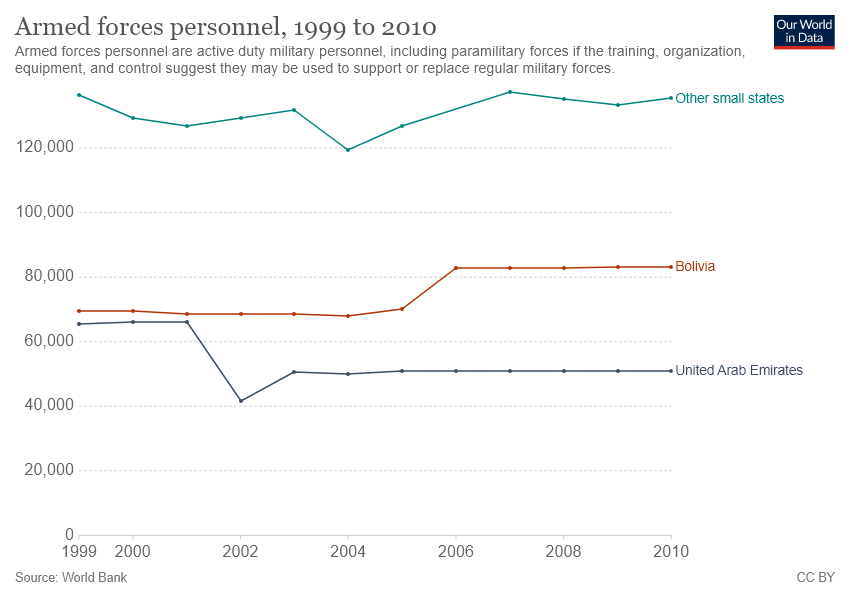Draw attention to some important aspects in this diagram. In the year 2002, the number of armed forces personnel in the United Arab Emirates was the smallest. The number of armed forces personnel in the United Arab Emirates has remained the same for the past 6 years. 